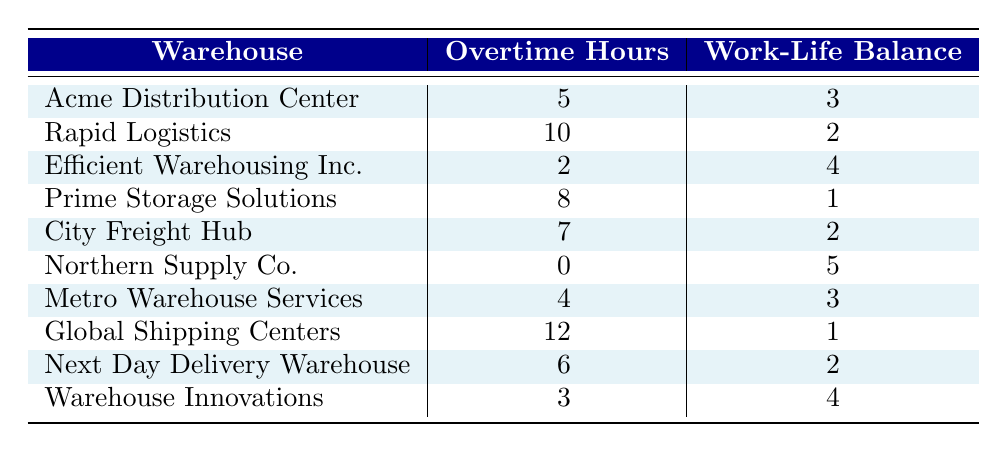What is the work-life balance perception at Northern Supply Co.? From the table, the row corresponding to Northern Supply Co. shows an overtime hour value of 0 and a work-life balance perception value of 5.
Answer: 5 Which warehouse has the highest overtime hours? By examining the "Overtime Hours" column, the maximum value is 12, which corresponds to Global Shipping Centers.
Answer: Global Shipping Centers Is there a warehouse where overtime hours are 4 and the work-life balance perception is 3? Checking the table, Metro Warehouse Services has 4 overtime hours and a work-life balance perception of 3, which confirms the statement is true.
Answer: Yes What is the average work-life balance perception for warehouses with 6 or more overtime hours? The warehouses with 6 or more overtime hours are Rapid Logistics (2), Prime Storage Solutions (1), Global Shipping Centers (1), and Next Day Delivery Warehouse (2). Adding these values gives 2 + 1 + 1 + 2 = 6. There are 4 warehouses, so the average is 6 / 4 = 1.5.
Answer: 1.5 Which warehouse has the lowest work-life balance perception? From the table, Prime Storage Solutions and Global Shipping Centers both have a work-life balance perception value of 1, which is the lowest.
Answer: Prime Storage Solutions and Global Shipping Centers What is the total number of overtime hours for warehouses with a work-life balance perception of 4? Looking at the table, Efficient Warehousing Inc. (2 overtime hours) and Warehouse Innovations (3 overtime hours) have a perception of 4. Adding these values gives 2 + 3 = 5.
Answer: 5 Is the work-life balance perception always lower when overtime hours are higher? Observing the data, the highest overtime hours (12) correspond to the lowest work-life balance perception (1), while Northern Supply Co. with 0 overtime hours has the highest perception (5). This indicates the statement is not always true.
Answer: No What is the difference in work-life balance perception between the warehouse with the highest overtime hours and that with the lowest? Global Shipping Centers has the highest overtime hours at 12 with a work-life balance perception of 1, and Northern Supply Co. has the lowest overtime hours at 0 with a perception of 5. The difference is 5 - 1 = 4.
Answer: 4 